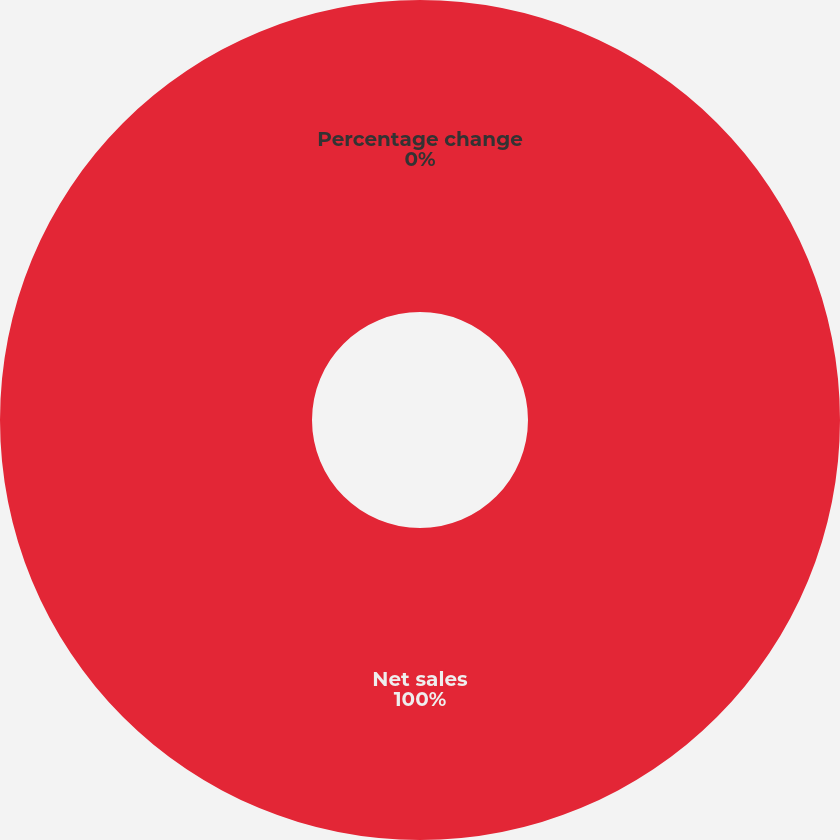Convert chart. <chart><loc_0><loc_0><loc_500><loc_500><pie_chart><fcel>Net sales<fcel>Percentage change<nl><fcel>100.0%<fcel>0.0%<nl></chart> 